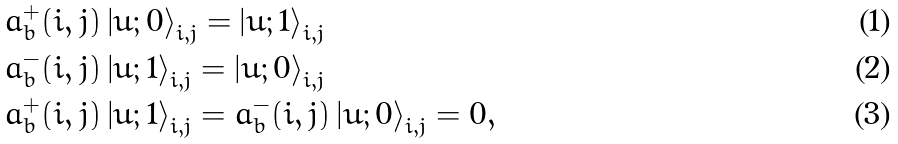<formula> <loc_0><loc_0><loc_500><loc_500>& a _ { b } ^ { + } ( i , j ) \left | u ; 0 \right > _ { i , j } = \left | u ; 1 \right > _ { i , j } \\ & a _ { b } ^ { - } ( i , j ) \left | u ; 1 \right > _ { i , j } = \left | u ; 0 \right > _ { i , j } \\ & a _ { b } ^ { + } ( i , j ) \left | u ; 1 \right > _ { i , j } = a _ { b } ^ { - } ( i , j ) \left | u ; 0 \right > _ { i , j } = 0 ,</formula> 